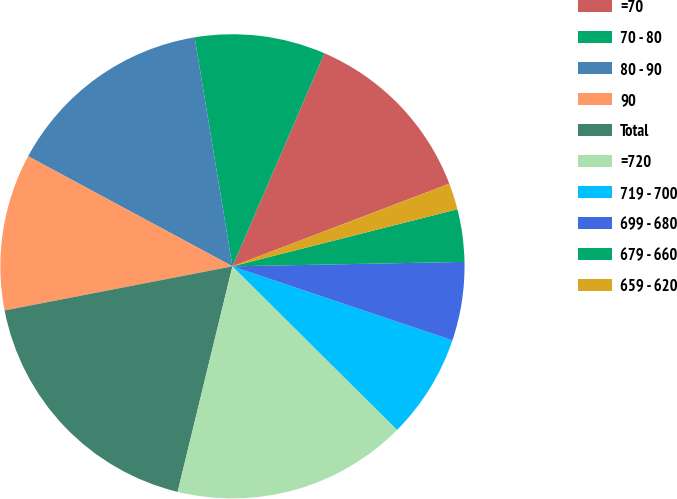Convert chart. <chart><loc_0><loc_0><loc_500><loc_500><pie_chart><fcel>=70<fcel>70 - 80<fcel>80 - 90<fcel>90<fcel>Total<fcel>=720<fcel>719 - 700<fcel>699 - 680<fcel>679 - 660<fcel>659 - 620<nl><fcel>12.72%<fcel>9.09%<fcel>14.53%<fcel>10.91%<fcel>18.16%<fcel>16.35%<fcel>7.28%<fcel>5.47%<fcel>3.65%<fcel>1.84%<nl></chart> 